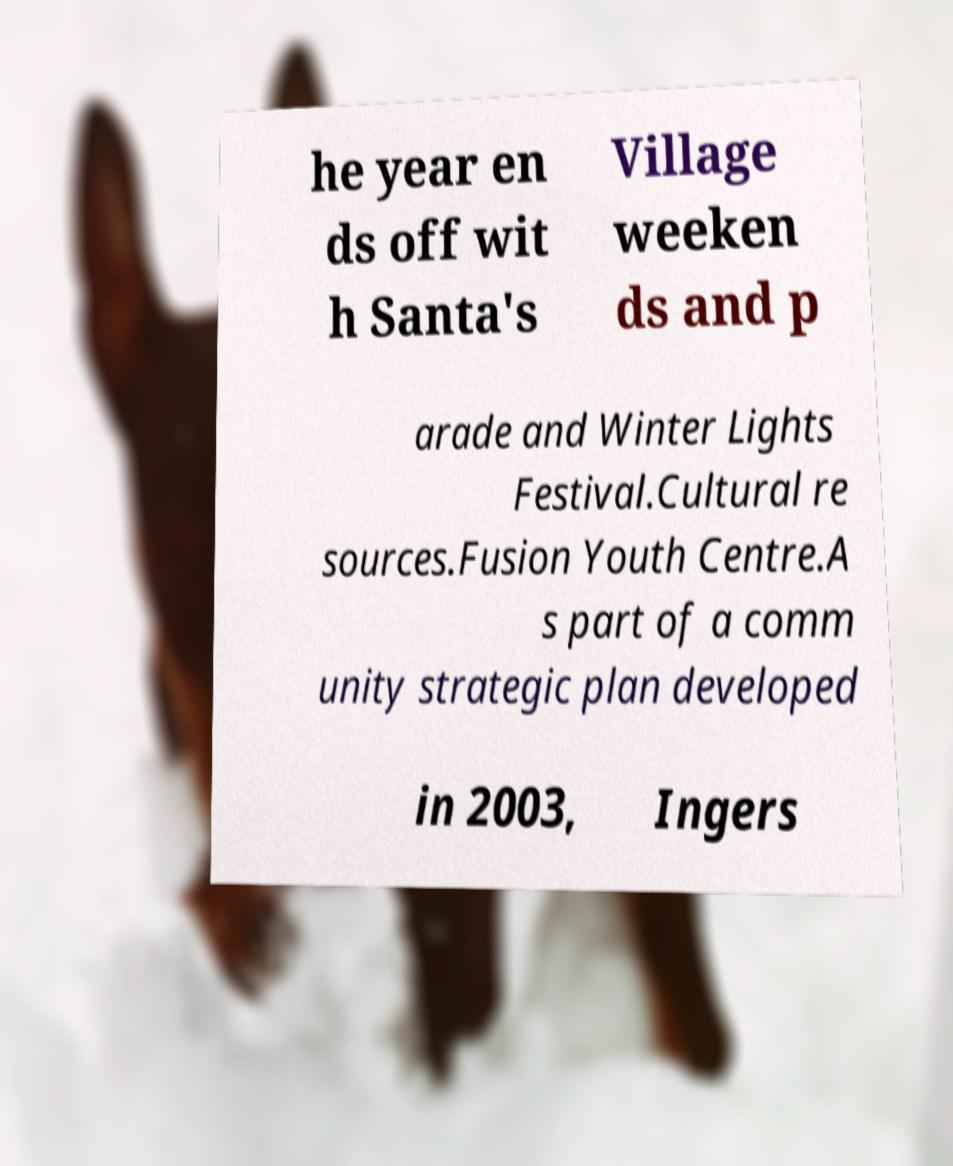There's text embedded in this image that I need extracted. Can you transcribe it verbatim? he year en ds off wit h Santa's Village weeken ds and p arade and Winter Lights Festival.Cultural re sources.Fusion Youth Centre.A s part of a comm unity strategic plan developed in 2003, Ingers 